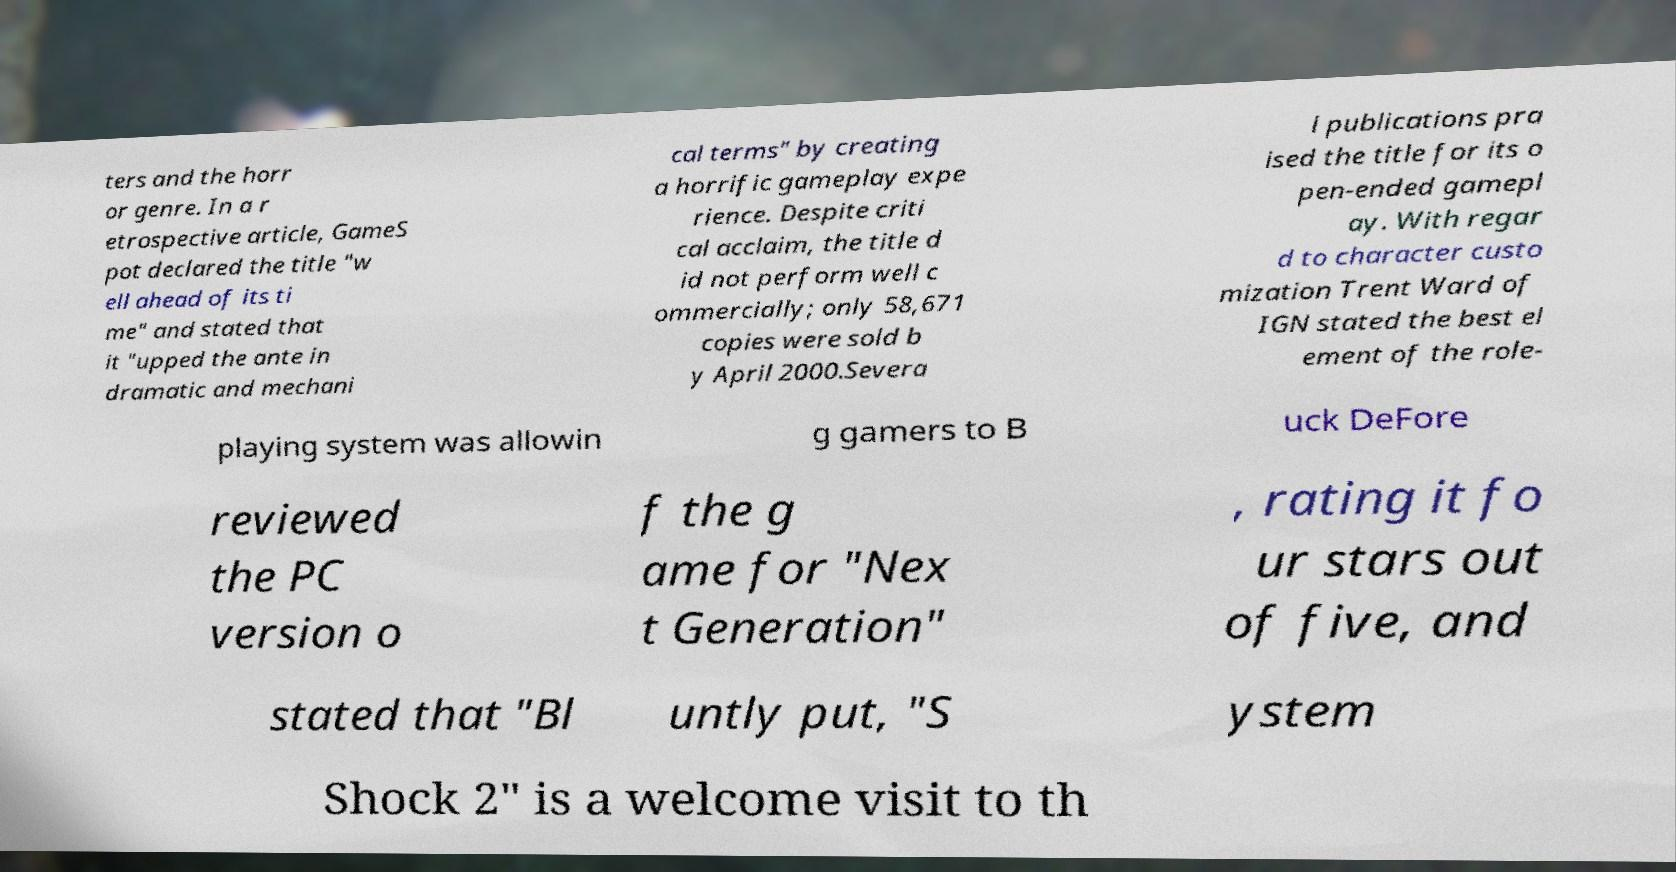What messages or text are displayed in this image? I need them in a readable, typed format. ters and the horr or genre. In a r etrospective article, GameS pot declared the title "w ell ahead of its ti me" and stated that it "upped the ante in dramatic and mechani cal terms" by creating a horrific gameplay expe rience. Despite criti cal acclaim, the title d id not perform well c ommercially; only 58,671 copies were sold b y April 2000.Severa l publications pra ised the title for its o pen-ended gamepl ay. With regar d to character custo mization Trent Ward of IGN stated the best el ement of the role- playing system was allowin g gamers to B uck DeFore reviewed the PC version o f the g ame for "Nex t Generation" , rating it fo ur stars out of five, and stated that "Bl untly put, "S ystem Shock 2" is a welcome visit to th 